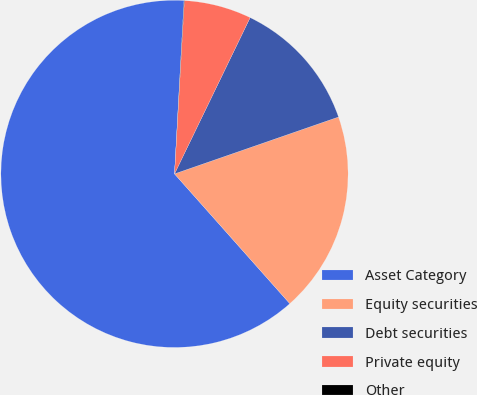Convert chart. <chart><loc_0><loc_0><loc_500><loc_500><pie_chart><fcel>Asset Category<fcel>Equity securities<fcel>Debt securities<fcel>Private equity<fcel>Other<nl><fcel>62.43%<fcel>18.75%<fcel>12.51%<fcel>6.27%<fcel>0.03%<nl></chart> 